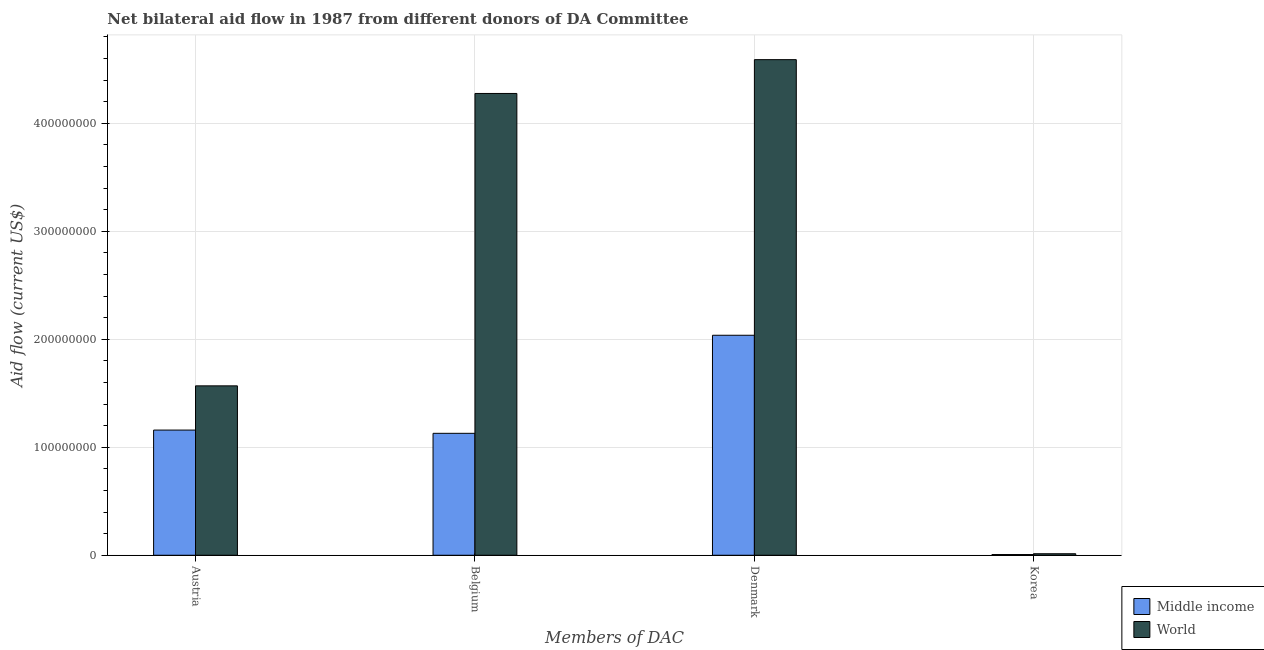How many different coloured bars are there?
Offer a terse response. 2. How many groups of bars are there?
Your answer should be compact. 4. Are the number of bars on each tick of the X-axis equal?
Ensure brevity in your answer.  Yes. How many bars are there on the 2nd tick from the left?
Make the answer very short. 2. How many bars are there on the 2nd tick from the right?
Your answer should be compact. 2. What is the amount of aid given by denmark in World?
Provide a short and direct response. 4.59e+08. Across all countries, what is the maximum amount of aid given by korea?
Keep it short and to the point. 1.40e+06. Across all countries, what is the minimum amount of aid given by belgium?
Give a very brief answer. 1.13e+08. In which country was the amount of aid given by korea maximum?
Give a very brief answer. World. In which country was the amount of aid given by korea minimum?
Give a very brief answer. Middle income. What is the total amount of aid given by korea in the graph?
Offer a very short reply. 2.07e+06. What is the difference between the amount of aid given by korea in World and that in Middle income?
Make the answer very short. 7.30e+05. What is the difference between the amount of aid given by austria in Middle income and the amount of aid given by belgium in World?
Give a very brief answer. -3.12e+08. What is the average amount of aid given by belgium per country?
Keep it short and to the point. 2.70e+08. What is the difference between the amount of aid given by austria and amount of aid given by korea in World?
Offer a very short reply. 1.56e+08. What is the ratio of the amount of aid given by korea in Middle income to that in World?
Provide a short and direct response. 0.48. Is the difference between the amount of aid given by belgium in World and Middle income greater than the difference between the amount of aid given by austria in World and Middle income?
Make the answer very short. Yes. What is the difference between the highest and the second highest amount of aid given by korea?
Offer a terse response. 7.30e+05. What is the difference between the highest and the lowest amount of aid given by austria?
Offer a very short reply. 4.10e+07. In how many countries, is the amount of aid given by austria greater than the average amount of aid given by austria taken over all countries?
Your answer should be compact. 1. What does the 1st bar from the left in Denmark represents?
Your answer should be compact. Middle income. What is the difference between two consecutive major ticks on the Y-axis?
Ensure brevity in your answer.  1.00e+08. Does the graph contain any zero values?
Offer a terse response. No. How many legend labels are there?
Offer a very short reply. 2. What is the title of the graph?
Your response must be concise. Net bilateral aid flow in 1987 from different donors of DA Committee. Does "Middle East & North Africa (all income levels)" appear as one of the legend labels in the graph?
Your answer should be very brief. No. What is the label or title of the X-axis?
Keep it short and to the point. Members of DAC. What is the label or title of the Y-axis?
Provide a short and direct response. Aid flow (current US$). What is the Aid flow (current US$) of Middle income in Austria?
Provide a succinct answer. 1.16e+08. What is the Aid flow (current US$) of World in Austria?
Keep it short and to the point. 1.57e+08. What is the Aid flow (current US$) of Middle income in Belgium?
Offer a very short reply. 1.13e+08. What is the Aid flow (current US$) in World in Belgium?
Your answer should be compact. 4.28e+08. What is the Aid flow (current US$) of Middle income in Denmark?
Offer a terse response. 2.04e+08. What is the Aid flow (current US$) in World in Denmark?
Keep it short and to the point. 4.59e+08. What is the Aid flow (current US$) of Middle income in Korea?
Give a very brief answer. 6.70e+05. What is the Aid flow (current US$) of World in Korea?
Give a very brief answer. 1.40e+06. Across all Members of DAC, what is the maximum Aid flow (current US$) of Middle income?
Ensure brevity in your answer.  2.04e+08. Across all Members of DAC, what is the maximum Aid flow (current US$) of World?
Your answer should be compact. 4.59e+08. Across all Members of DAC, what is the minimum Aid flow (current US$) of Middle income?
Your response must be concise. 6.70e+05. Across all Members of DAC, what is the minimum Aid flow (current US$) in World?
Make the answer very short. 1.40e+06. What is the total Aid flow (current US$) in Middle income in the graph?
Offer a terse response. 4.33e+08. What is the total Aid flow (current US$) in World in the graph?
Your answer should be compact. 1.05e+09. What is the difference between the Aid flow (current US$) of Middle income in Austria and that in Belgium?
Your response must be concise. 3.01e+06. What is the difference between the Aid flow (current US$) of World in Austria and that in Belgium?
Offer a terse response. -2.71e+08. What is the difference between the Aid flow (current US$) of Middle income in Austria and that in Denmark?
Your answer should be very brief. -8.78e+07. What is the difference between the Aid flow (current US$) of World in Austria and that in Denmark?
Give a very brief answer. -3.02e+08. What is the difference between the Aid flow (current US$) of Middle income in Austria and that in Korea?
Make the answer very short. 1.15e+08. What is the difference between the Aid flow (current US$) in World in Austria and that in Korea?
Make the answer very short. 1.56e+08. What is the difference between the Aid flow (current US$) in Middle income in Belgium and that in Denmark?
Keep it short and to the point. -9.08e+07. What is the difference between the Aid flow (current US$) of World in Belgium and that in Denmark?
Keep it short and to the point. -3.13e+07. What is the difference between the Aid flow (current US$) in Middle income in Belgium and that in Korea?
Offer a very short reply. 1.12e+08. What is the difference between the Aid flow (current US$) of World in Belgium and that in Korea?
Provide a short and direct response. 4.26e+08. What is the difference between the Aid flow (current US$) of Middle income in Denmark and that in Korea?
Provide a succinct answer. 2.03e+08. What is the difference between the Aid flow (current US$) of World in Denmark and that in Korea?
Provide a short and direct response. 4.58e+08. What is the difference between the Aid flow (current US$) of Middle income in Austria and the Aid flow (current US$) of World in Belgium?
Provide a succinct answer. -3.12e+08. What is the difference between the Aid flow (current US$) in Middle income in Austria and the Aid flow (current US$) in World in Denmark?
Give a very brief answer. -3.43e+08. What is the difference between the Aid flow (current US$) in Middle income in Austria and the Aid flow (current US$) in World in Korea?
Provide a short and direct response. 1.15e+08. What is the difference between the Aid flow (current US$) of Middle income in Belgium and the Aid flow (current US$) of World in Denmark?
Your answer should be compact. -3.46e+08. What is the difference between the Aid flow (current US$) in Middle income in Belgium and the Aid flow (current US$) in World in Korea?
Offer a very short reply. 1.12e+08. What is the difference between the Aid flow (current US$) in Middle income in Denmark and the Aid flow (current US$) in World in Korea?
Provide a succinct answer. 2.02e+08. What is the average Aid flow (current US$) in Middle income per Members of DAC?
Your answer should be very brief. 1.08e+08. What is the average Aid flow (current US$) of World per Members of DAC?
Ensure brevity in your answer.  2.61e+08. What is the difference between the Aid flow (current US$) of Middle income and Aid flow (current US$) of World in Austria?
Provide a short and direct response. -4.10e+07. What is the difference between the Aid flow (current US$) in Middle income and Aid flow (current US$) in World in Belgium?
Provide a succinct answer. -3.15e+08. What is the difference between the Aid flow (current US$) of Middle income and Aid flow (current US$) of World in Denmark?
Make the answer very short. -2.55e+08. What is the difference between the Aid flow (current US$) in Middle income and Aid flow (current US$) in World in Korea?
Your answer should be very brief. -7.30e+05. What is the ratio of the Aid flow (current US$) in Middle income in Austria to that in Belgium?
Provide a short and direct response. 1.03. What is the ratio of the Aid flow (current US$) of World in Austria to that in Belgium?
Your answer should be very brief. 0.37. What is the ratio of the Aid flow (current US$) in Middle income in Austria to that in Denmark?
Keep it short and to the point. 0.57. What is the ratio of the Aid flow (current US$) in World in Austria to that in Denmark?
Make the answer very short. 0.34. What is the ratio of the Aid flow (current US$) in Middle income in Austria to that in Korea?
Your response must be concise. 173.06. What is the ratio of the Aid flow (current US$) of World in Austria to that in Korea?
Make the answer very short. 112.07. What is the ratio of the Aid flow (current US$) of Middle income in Belgium to that in Denmark?
Make the answer very short. 0.55. What is the ratio of the Aid flow (current US$) in World in Belgium to that in Denmark?
Ensure brevity in your answer.  0.93. What is the ratio of the Aid flow (current US$) in Middle income in Belgium to that in Korea?
Offer a terse response. 168.57. What is the ratio of the Aid flow (current US$) of World in Belgium to that in Korea?
Give a very brief answer. 305.5. What is the ratio of the Aid flow (current US$) of Middle income in Denmark to that in Korea?
Keep it short and to the point. 304.12. What is the ratio of the Aid flow (current US$) in World in Denmark to that in Korea?
Provide a succinct answer. 327.86. What is the difference between the highest and the second highest Aid flow (current US$) of Middle income?
Offer a terse response. 8.78e+07. What is the difference between the highest and the second highest Aid flow (current US$) in World?
Your response must be concise. 3.13e+07. What is the difference between the highest and the lowest Aid flow (current US$) in Middle income?
Your response must be concise. 2.03e+08. What is the difference between the highest and the lowest Aid flow (current US$) in World?
Your answer should be compact. 4.58e+08. 